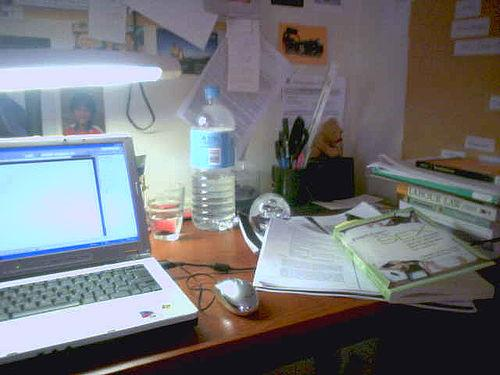What might sit in the glass? Please explain your reasoning. dentures. The glass has water in it already. 